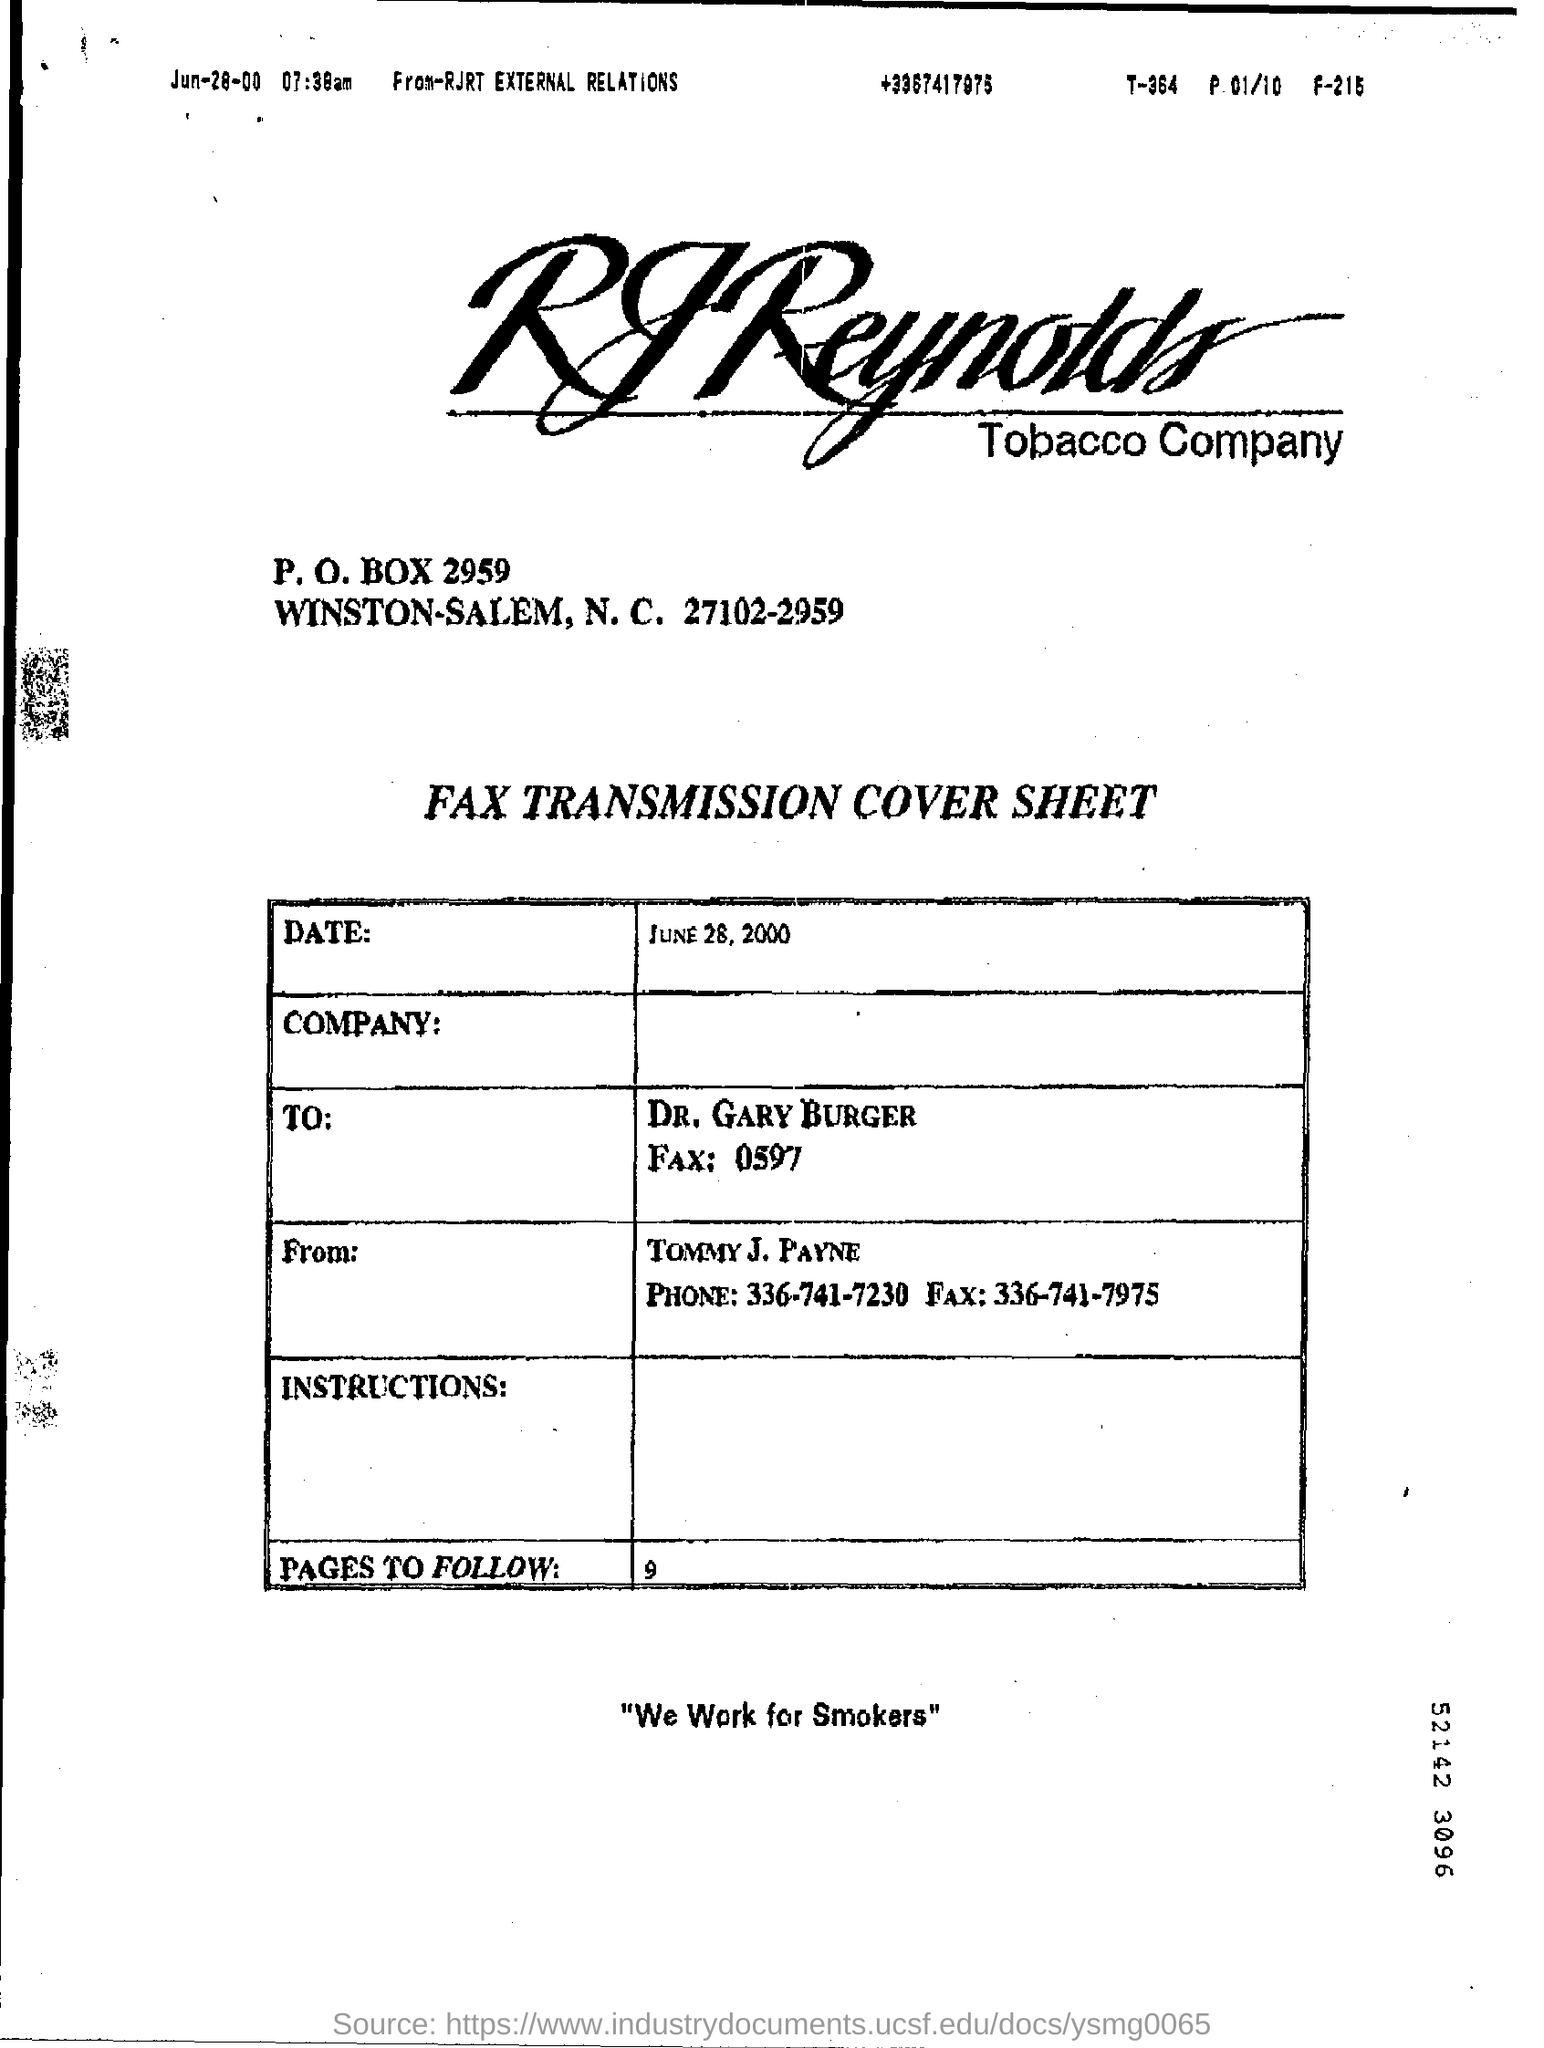List a handful of essential elements in this visual. There are 9 pages to follow. The recipient of the fax is Dr. Gary Burger. The fax number of Tommy J. Payne is 336-741-7975. The sender of the fax is Tommy J. Payne. 